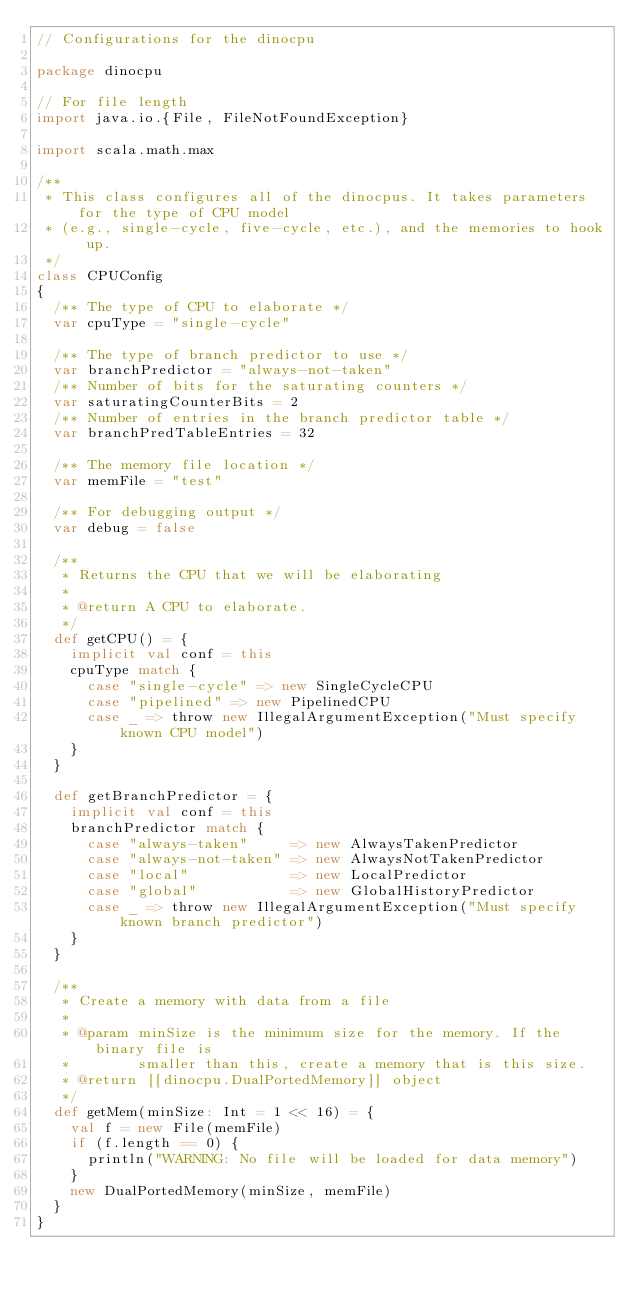<code> <loc_0><loc_0><loc_500><loc_500><_Scala_>// Configurations for the dinocpu

package dinocpu

// For file length
import java.io.{File, FileNotFoundException}

import scala.math.max

/**
 * This class configures all of the dinocpus. It takes parameters for the type of CPU model
 * (e.g., single-cycle, five-cycle, etc.), and the memories to hook up.
 */
class CPUConfig
{
  /** The type of CPU to elaborate */
  var cpuType = "single-cycle"

  /** The type of branch predictor to use */
  var branchPredictor = "always-not-taken"
  /** Number of bits for the saturating counters */
  var saturatingCounterBits = 2
  /** Number of entries in the branch predictor table */
  var branchPredTableEntries = 32

  /** The memory file location */
  var memFile = "test"

  /** For debugging output */
  var debug = false

  /**
   * Returns the CPU that we will be elaborating
   *
   * @return A CPU to elaborate.
   */
  def getCPU() = {
    implicit val conf = this
    cpuType match {
      case "single-cycle" => new SingleCycleCPU
      case "pipelined" => new PipelinedCPU
      case _ => throw new IllegalArgumentException("Must specify known CPU model")
    }
  }

  def getBranchPredictor = {
    implicit val conf = this
    branchPredictor match {
      case "always-taken"     => new AlwaysTakenPredictor
      case "always-not-taken" => new AlwaysNotTakenPredictor
      case "local"            => new LocalPredictor
      case "global"           => new GlobalHistoryPredictor
      case _ => throw new IllegalArgumentException("Must specify known branch predictor")
    }
  }

  /**
   * Create a memory with data from a file
   *
   * @param minSize is the minimum size for the memory. If the binary file is
   *        smaller than this, create a memory that is this size.
   * @return [[dinocpu.DualPortedMemory]] object
   */
  def getMem(minSize: Int = 1 << 16) = {
    val f = new File(memFile)
    if (f.length == 0) {
      println("WARNING: No file will be loaded for data memory")
    }
    new DualPortedMemory(minSize, memFile)
  }
}
</code> 